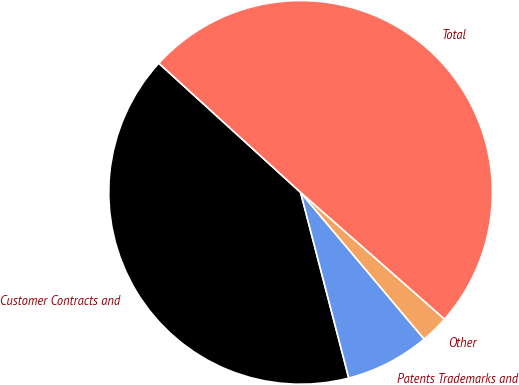Convert chart to OTSL. <chart><loc_0><loc_0><loc_500><loc_500><pie_chart><fcel>Customer Contracts and<fcel>Patents Trademarks and<fcel>Other<fcel>Total<nl><fcel>40.8%<fcel>7.1%<fcel>2.37%<fcel>49.73%<nl></chart> 